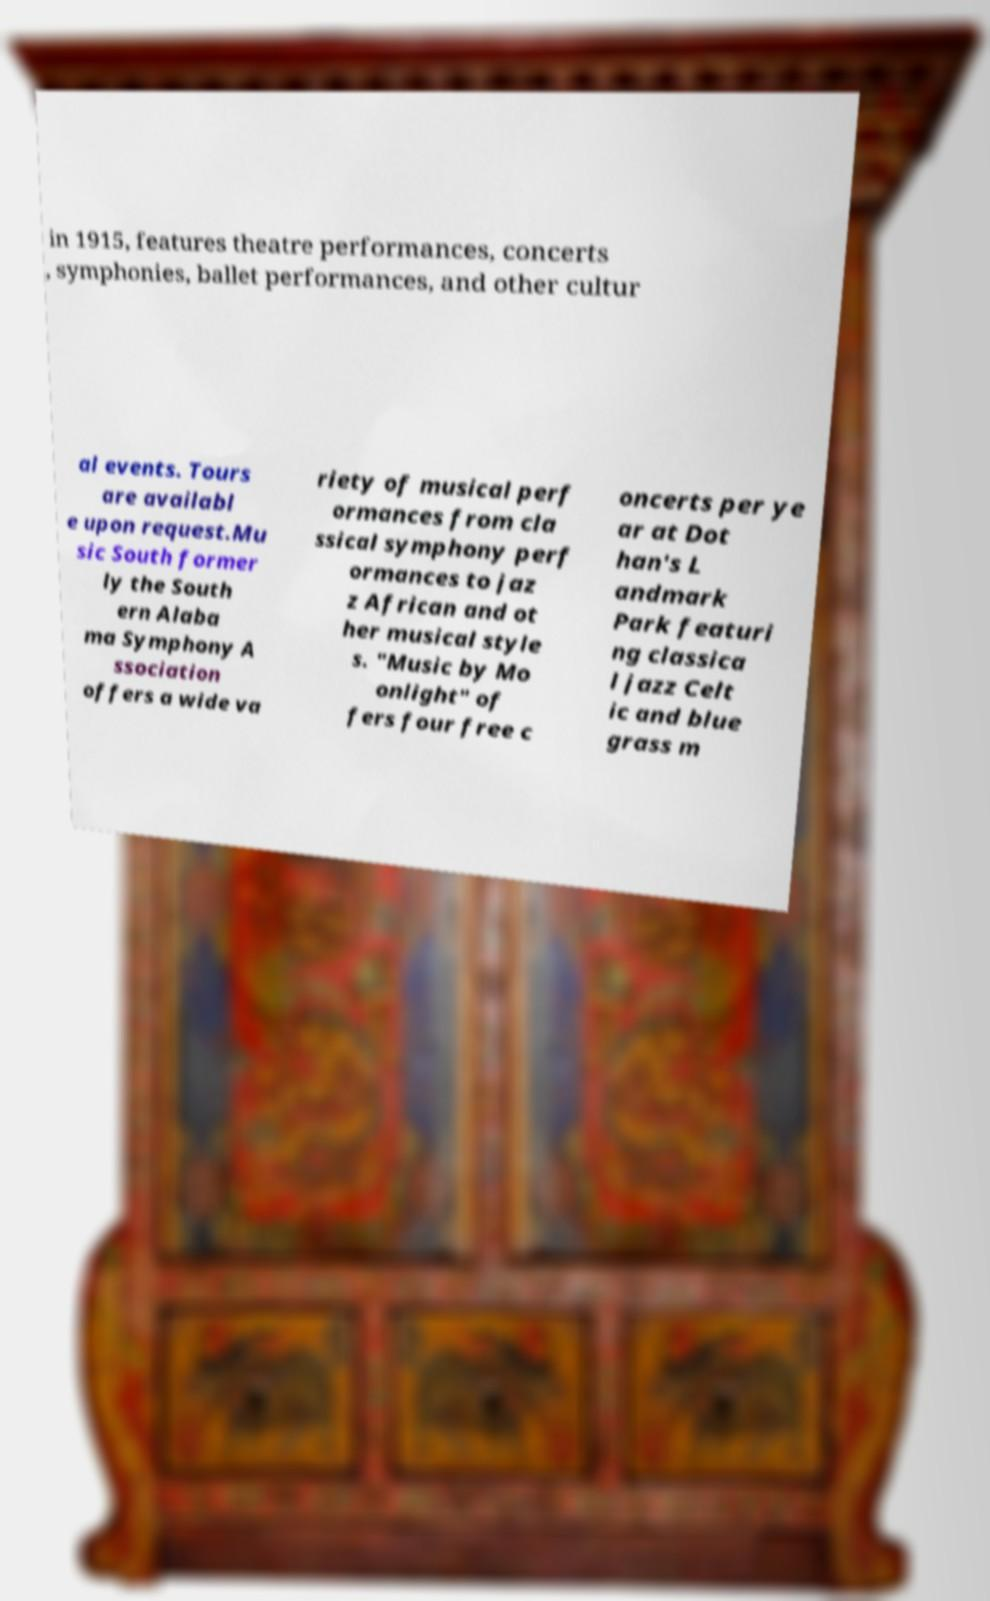Could you assist in decoding the text presented in this image and type it out clearly? in 1915, features theatre performances, concerts , symphonies, ballet performances, and other cultur al events. Tours are availabl e upon request.Mu sic South former ly the South ern Alaba ma Symphony A ssociation offers a wide va riety of musical perf ormances from cla ssical symphony perf ormances to jaz z African and ot her musical style s. "Music by Mo onlight" of fers four free c oncerts per ye ar at Dot han's L andmark Park featuri ng classica l jazz Celt ic and blue grass m 